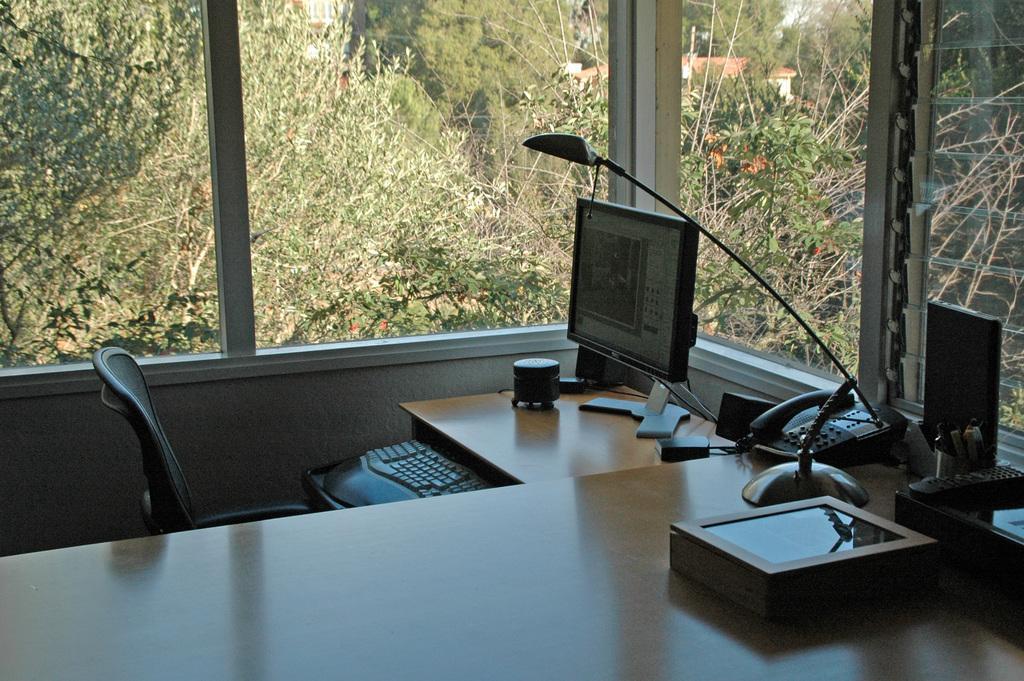Describe this image in one or two sentences. Inside the room there is a table. On the table there is a box, pens, telephone, lamp, monitor, keyboard, black color chair. And we can see the windows. Behind the window there are trees. We can also see a remote on the table. 